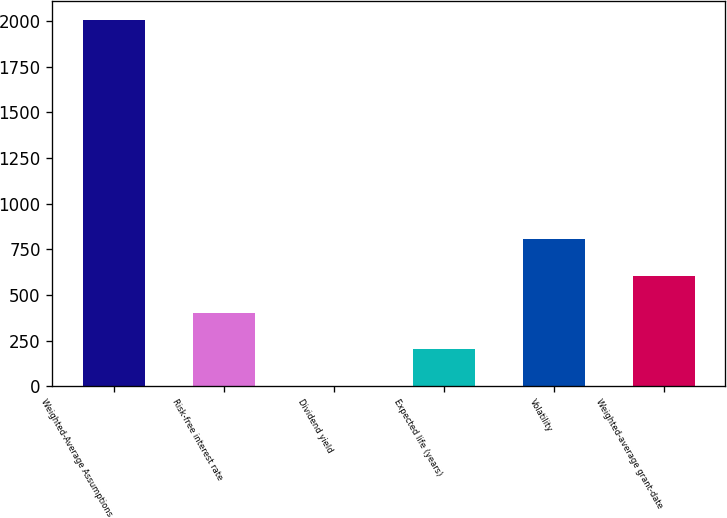Convert chart. <chart><loc_0><loc_0><loc_500><loc_500><bar_chart><fcel>Weighted-Average Assumptions<fcel>Risk-free interest rate<fcel>Dividend yield<fcel>Expected life (years)<fcel>Volatility<fcel>Weighted-average grant-date<nl><fcel>2007<fcel>402.52<fcel>1.4<fcel>201.96<fcel>803.64<fcel>603.08<nl></chart> 